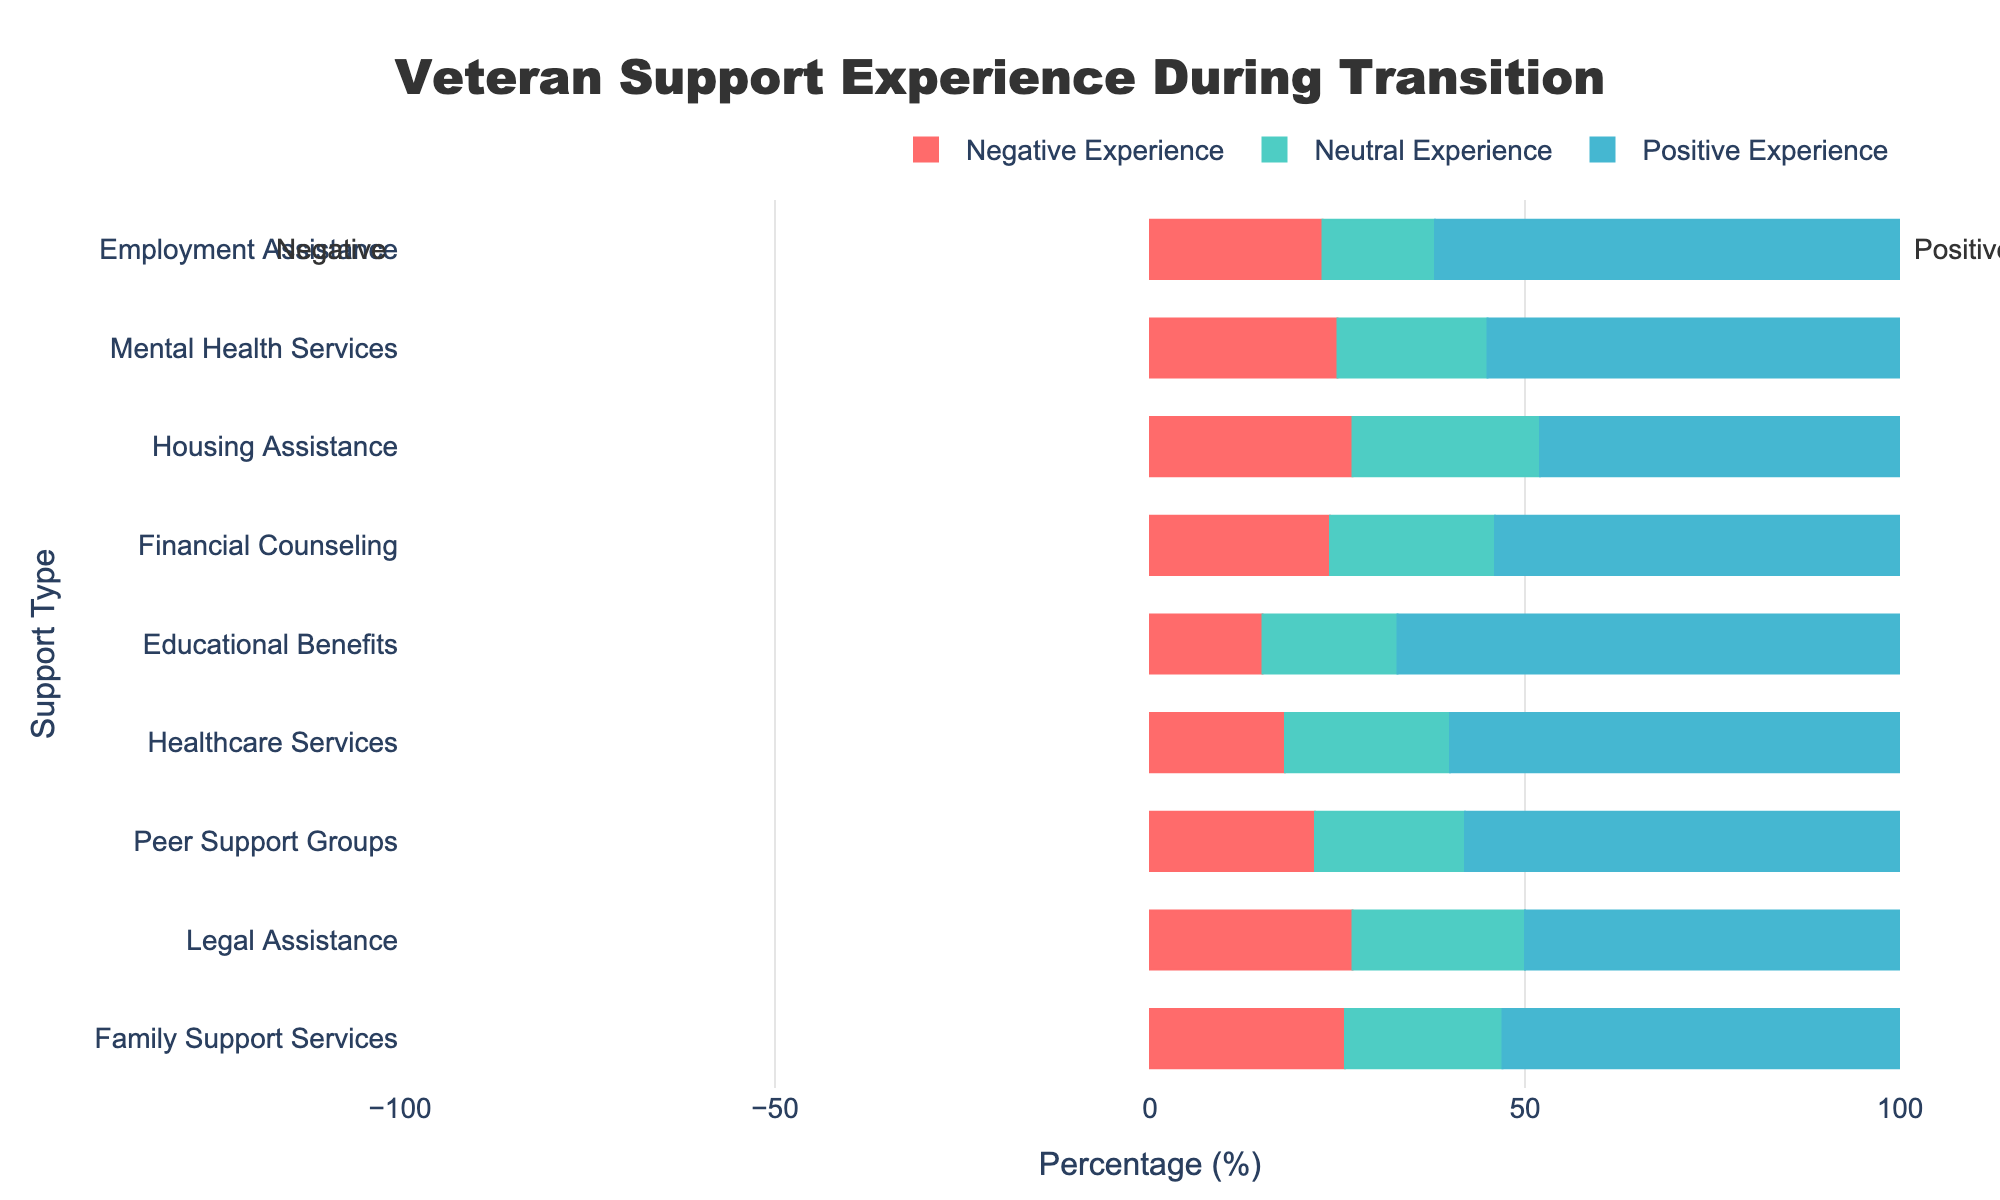what percentage of veterans reported a positive experience with employment assistance? Locate the bar labeled 'Employment Assistance' and note its section in the positive experience color (blue). The figure indicates that it is at 62%.
Answer: 62% Which support services have a higher percentage of positive experiences compared to negative experiences? Review each support service bar and compare the positive experience section with the negative experience section. Positive is greater than negative for Employment Assistance, Mental Health Services, Financial Counseling, Educational Benefits, Healthcare Services, Peer Support Groups, and Family Support Services.
Answer: Employment Assistance, Mental Health Services, Financial Counseling, Educational Benefits, Healthcare Services, Peer Support Groups, Family Support Services What is the total percentage of positive plus neutral experiences in housing assistance? Sum the percentages of positive (48%) and neutral (25%) experiences for Housing Assistance. 48% + 25% = 73%
Answer: 73% Which support type has the highest negative experience percentage? Review the length of the negative experience sections in red. Housing Assistance and Legal Assistance both have the longest sections at 27%.
Answer: Housing Assistance, Legal Assistance What is the average percentage of neutral experiences across all support services? Add up the neutral experiences percentages for all services: (15 + 20 + 25 + 22 + 18 + 22 + 20 + 23 + 21) = 186. Then divide by the number of services (9). 186 / 9 = 20.67%
Answer: 20.67% For which support type is the difference between positive and negative experiences the largest? Calculate the difference between the positive and negative percentages for each service and find the maximum. The differences are: Employment Assistance: 62 - 23 = 39, Mental Health Services: 55 - 25 = 30, etc. The largest difference is Educational Benefits: 67 - 15 = 52.
Answer: Educational Benefits Is there any support type where the neutral experiences are greater than both positive and negative experiences? Compare the neutral experience percentage with both positive and negative percentages for each support type. No support type meets this criterion.
Answer: No Which support service has the lowest percentage of negative experiences? Look at the negative experience (red) sections and find the shortest. Educational Benefits has the lowest negative percentage at 15%.
Answer: Educational Benefits How many support types have more positive experiences than the combined total of neutral and negative experiences? For each support type, determine if the positive percentage exceeds the sum of neutral and negative. Educational Benefits (67 > 18 + 15 = 33) is the only one that fits this criteria.
Answer: 1 What support type has an almost equal percentage of neutral and negative experiences? Compare the neutral and negative percentages, finding the smallest difference. Legal Assistance has neutral at 23% and negative at 27%, a difference of 4%.
Answer: Legal Assistance 